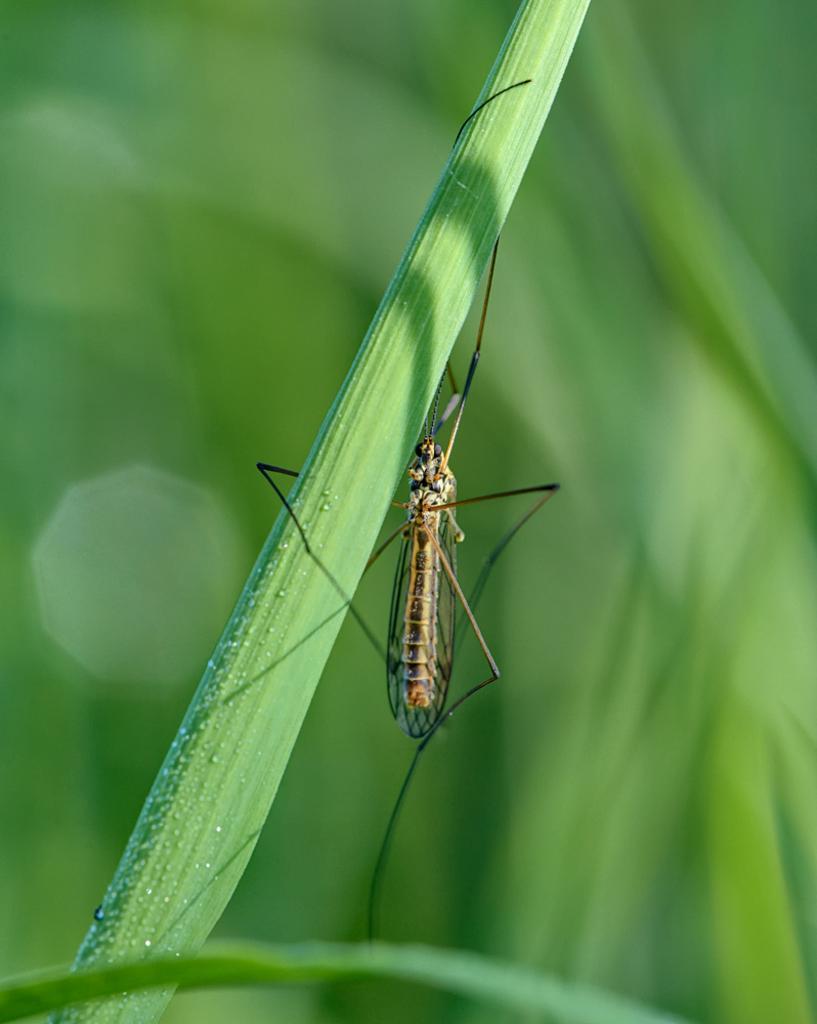Could you give a brief overview of what you see in this image? In the center of the image we can see a mosquito on the leaf. 